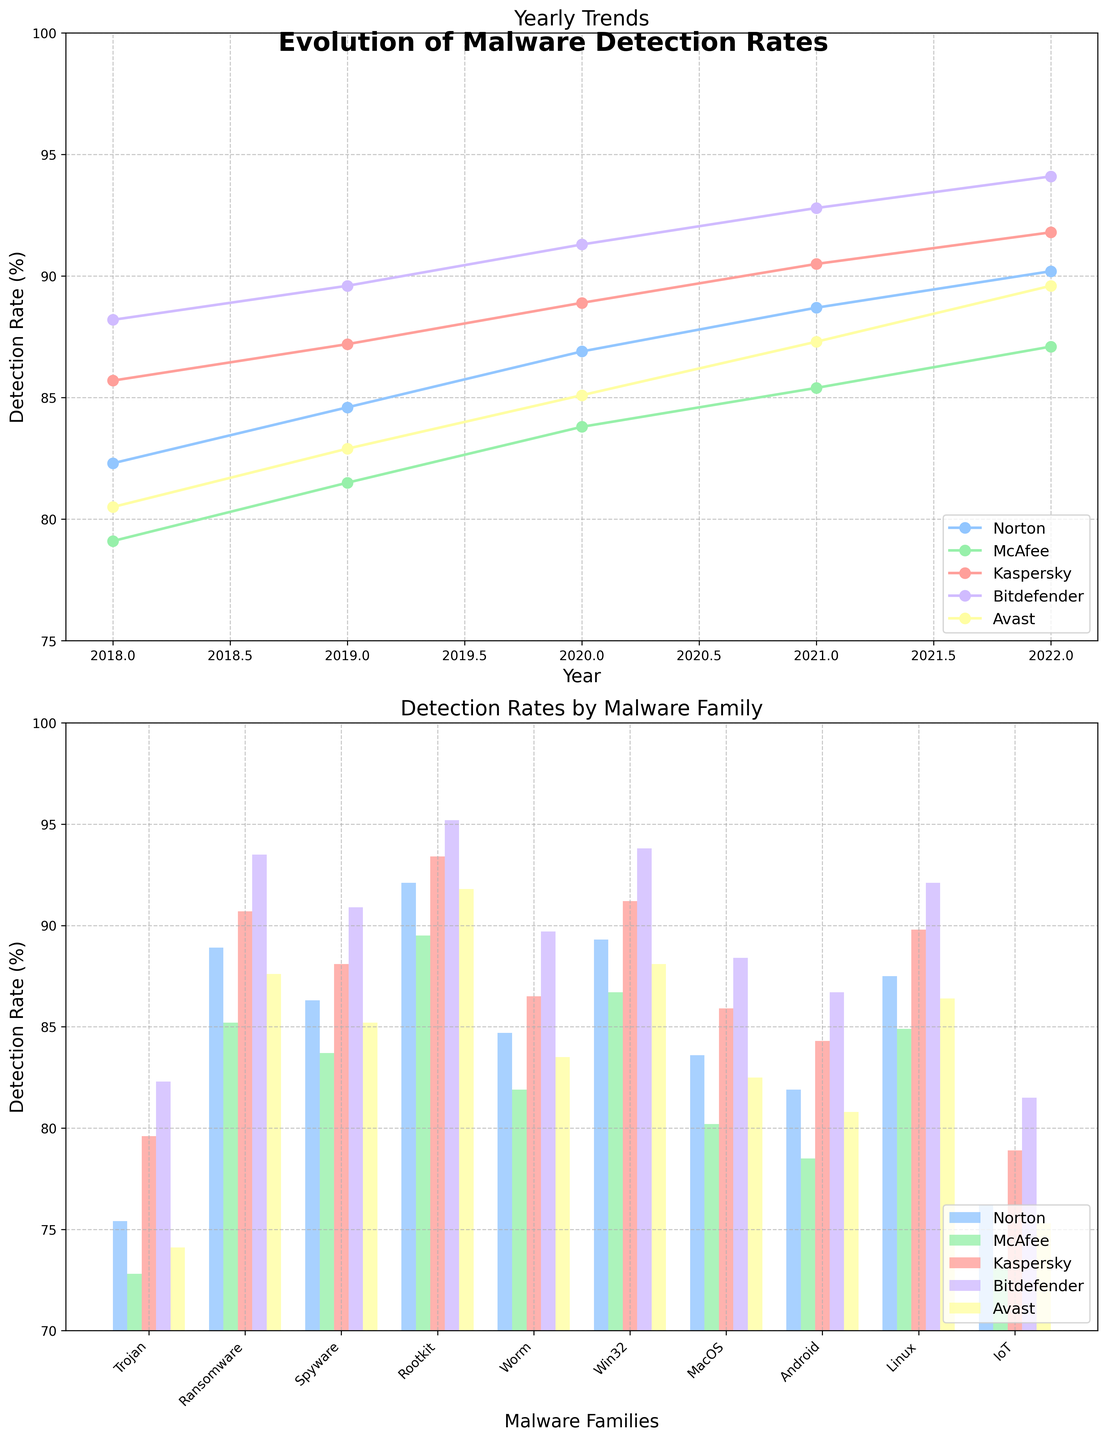Which antivirus software showed the highest detection rate in 2022? The bar graph shows the detection rates by malware family. Look for the highest detection rate among Norton, McAfee, Kaspersky, Bitdefender, and Avast.
Answer: Bitdefender Which antivirus had the lowest average detection rate across all malware families? To find the answer, find the detection rates for each antivirus software across all malware families, sum them up, and then divide by the number of malware families. Compare these averages to identify the lowest one.
Answer: McAfee Between Norton and Kaspersky, which software had a greater improvement in detection rates from 2018 to 2022? Calculate the difference in detection rates for Norton and Kaspersky from 2018 to 2022, then compare these improvements. Norton: 90.2 - 82.3 = 7.9, Kaspersky: 91.8 - 85.7 = 6.1.
Answer: Norton What was the detection rate for Ransomware by Bitdefender? Look for the height of the specific bar representing Bitdefender under the "Ransomware" category in the malware family bar chart.
Answer: 93.5% Which year had the highest overall detection rate for McAfee? Check the yearly line chart for McAfee and compare the detection rates on the y-axis for all years.
Answer: 2022 Comparing the detection rates for IoT and Trojan, which antivirus software showed the highest and lowest detection rates respectively? Check the heights of the bars in the malware family bar chart for IoT and Trojan categories. Identify the antivirus with the highest rate for IoT and the lowest for Trojan categories.
Answer: Highest for IoT: Bitdefender, Lowest for Trojan: McAfee What is the average detection rate for Linux across all antivirus software? Sum the detection rates of all antivirus software for Linux and divide by the number of software (87.5, 84.9, 89.8, 92.1, 86.4). Calculation: (87.5 + 84.9 + 89.8 + 92.1 + 86.4) / 5 = 88.14
Answer: 88.14 In which malware family category does Norton outperform the other antivirus software the most? For each malware family, compare Norton's detection rate with others and identify the category with the most significant difference where Norton is the highest. Check Ransomware: Norton 88.9, McAfee 85.2, Kaspersky 90.7, Bitdefender 93.5, Avast 87.6. Norton does not outperform in this one, check others similarly.
Answer: None 